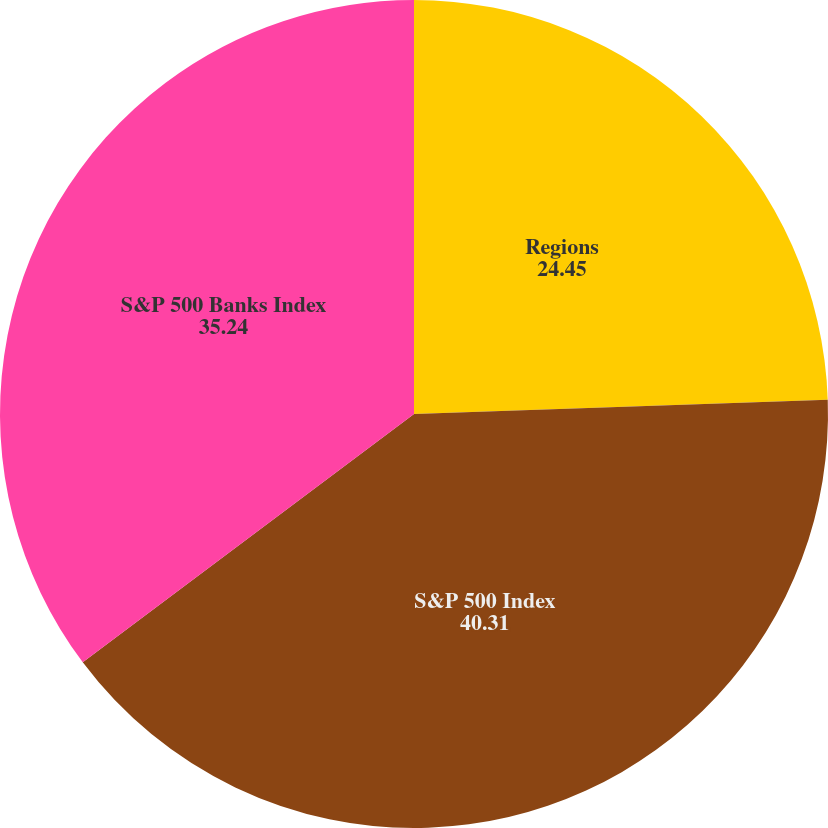Convert chart. <chart><loc_0><loc_0><loc_500><loc_500><pie_chart><fcel>Regions<fcel>S&P 500 Index<fcel>S&P 500 Banks Index<nl><fcel>24.45%<fcel>40.31%<fcel>35.24%<nl></chart> 